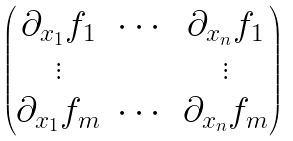<formula> <loc_0><loc_0><loc_500><loc_500>\begin{pmatrix} \partial _ { x _ { 1 } } f _ { 1 } & \cdots & \partial _ { x _ { n } } f _ { 1 } \\ \vdots & & \vdots \\ \partial _ { x _ { 1 } } f _ { m } & \cdots & \partial _ { x _ { n } } f _ { m } \end{pmatrix}</formula> 